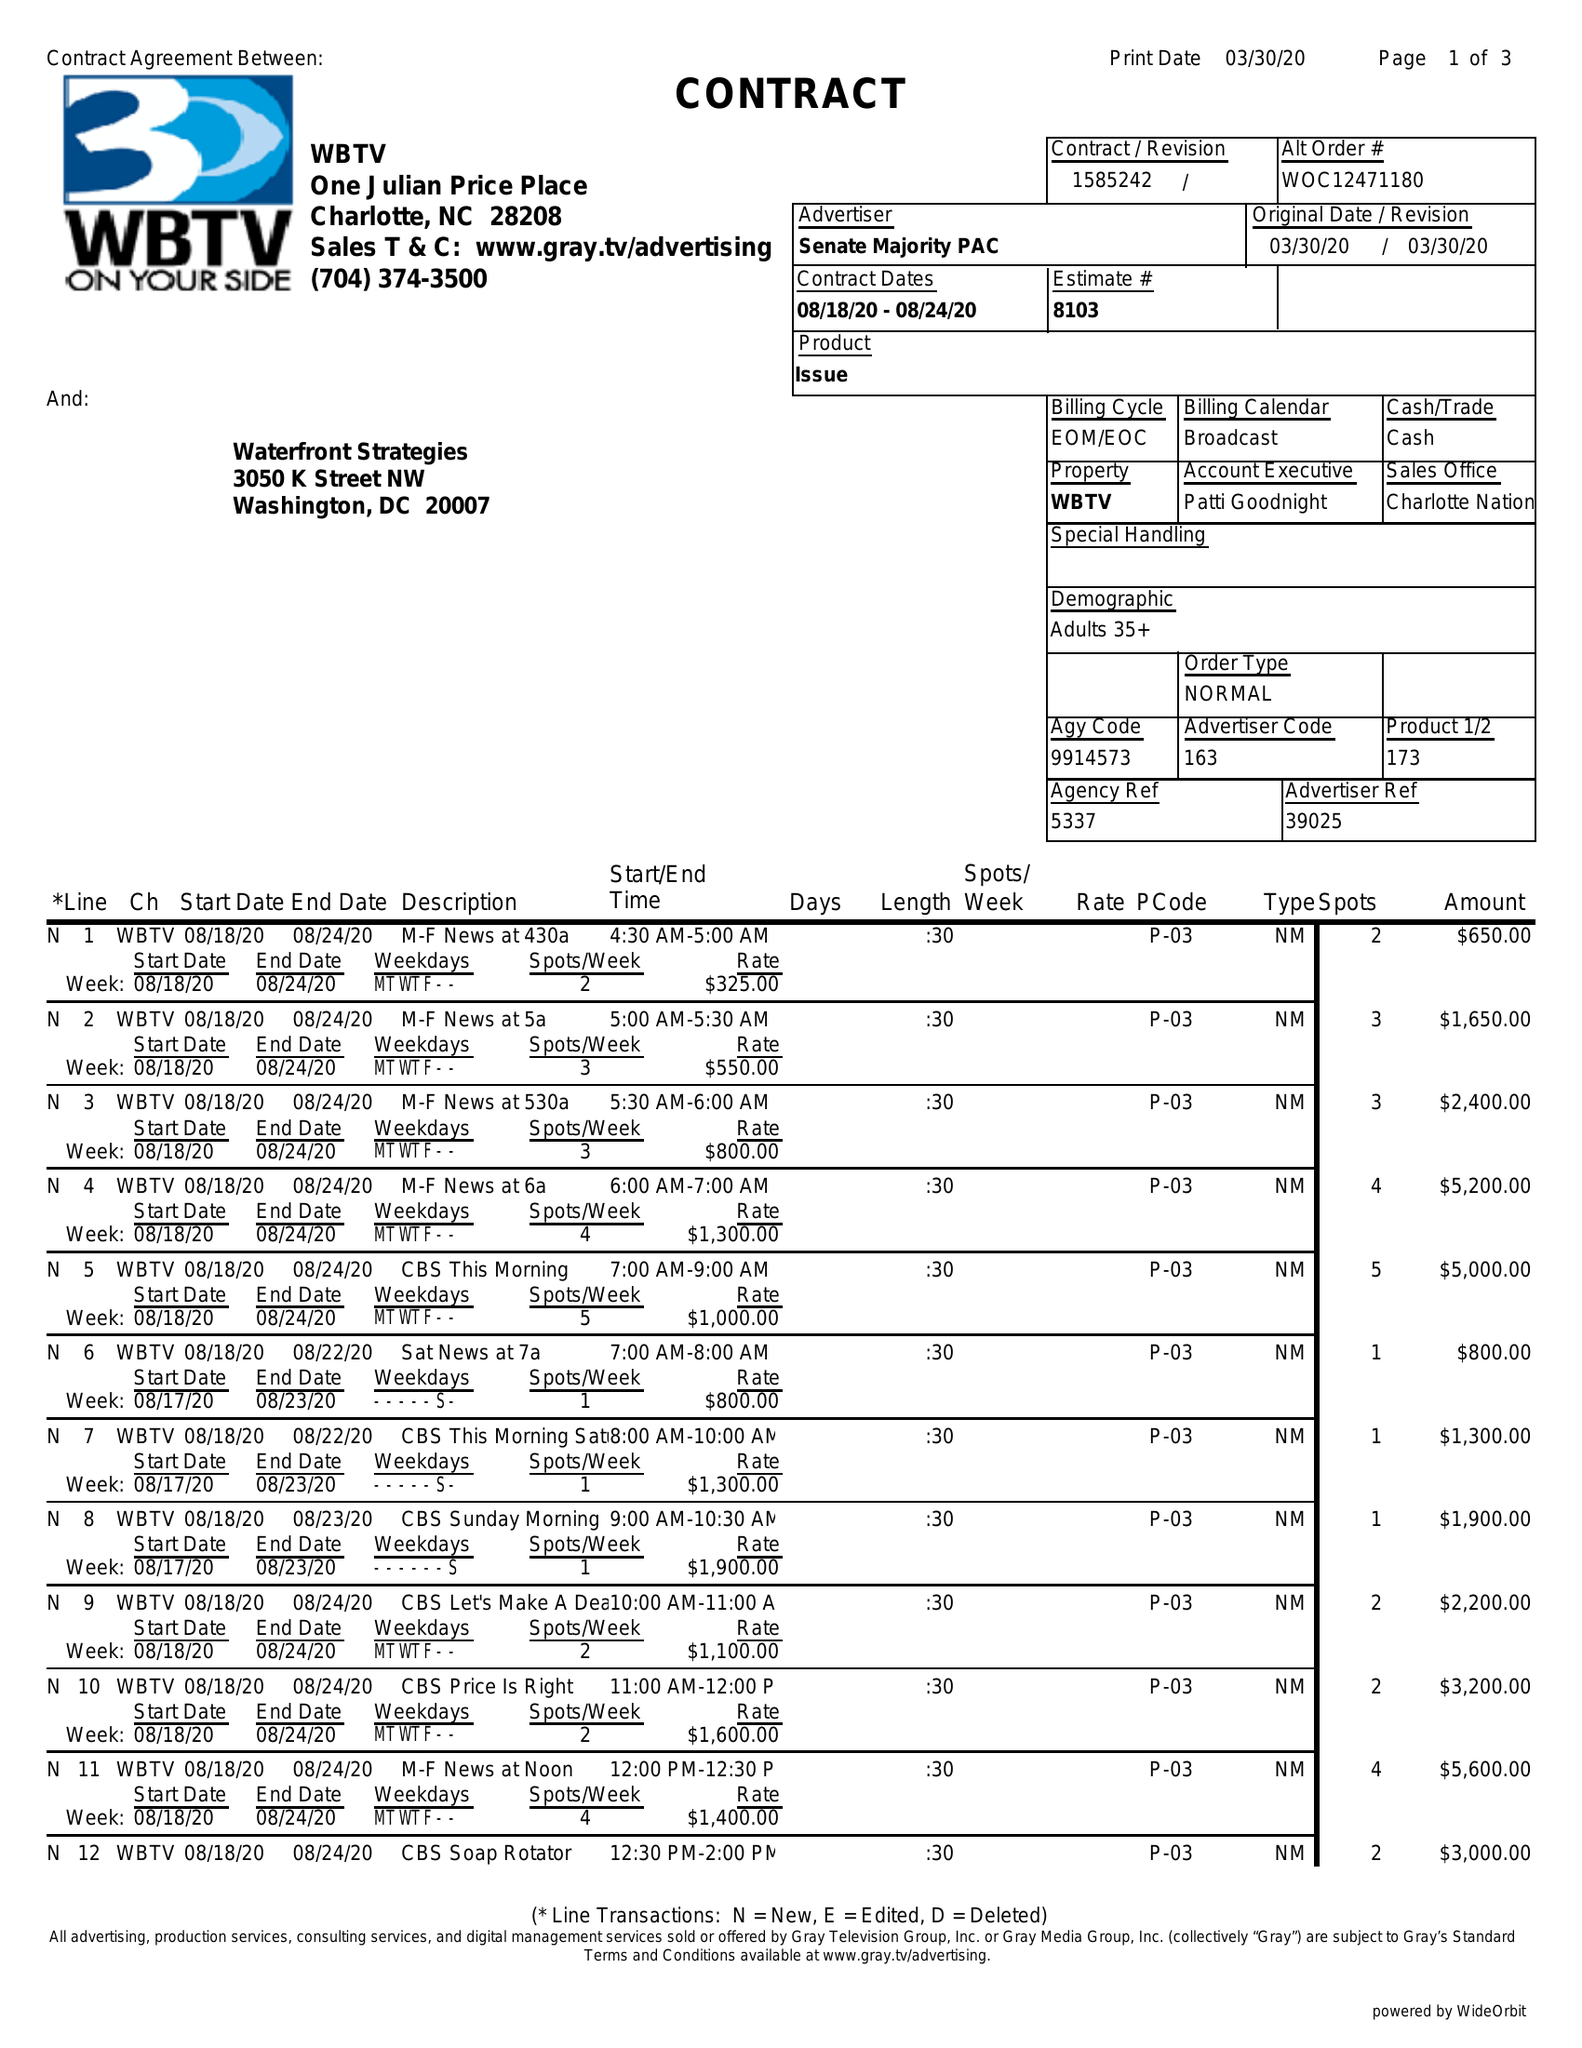What is the value for the advertiser?
Answer the question using a single word or phrase. SENATE MAJORITY PAC 